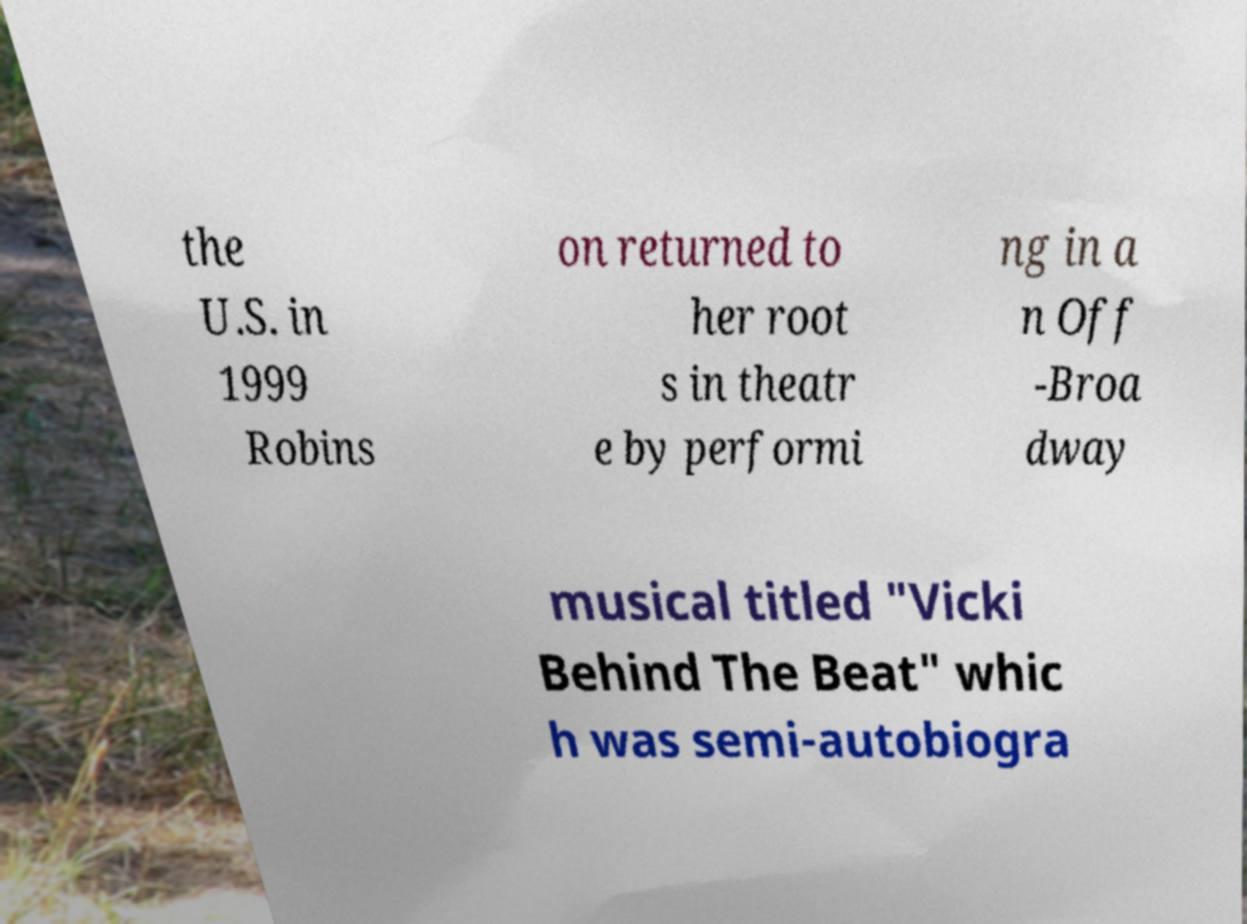There's text embedded in this image that I need extracted. Can you transcribe it verbatim? the U.S. in 1999 Robins on returned to her root s in theatr e by performi ng in a n Off -Broa dway musical titled "Vicki Behind The Beat" whic h was semi-autobiogra 